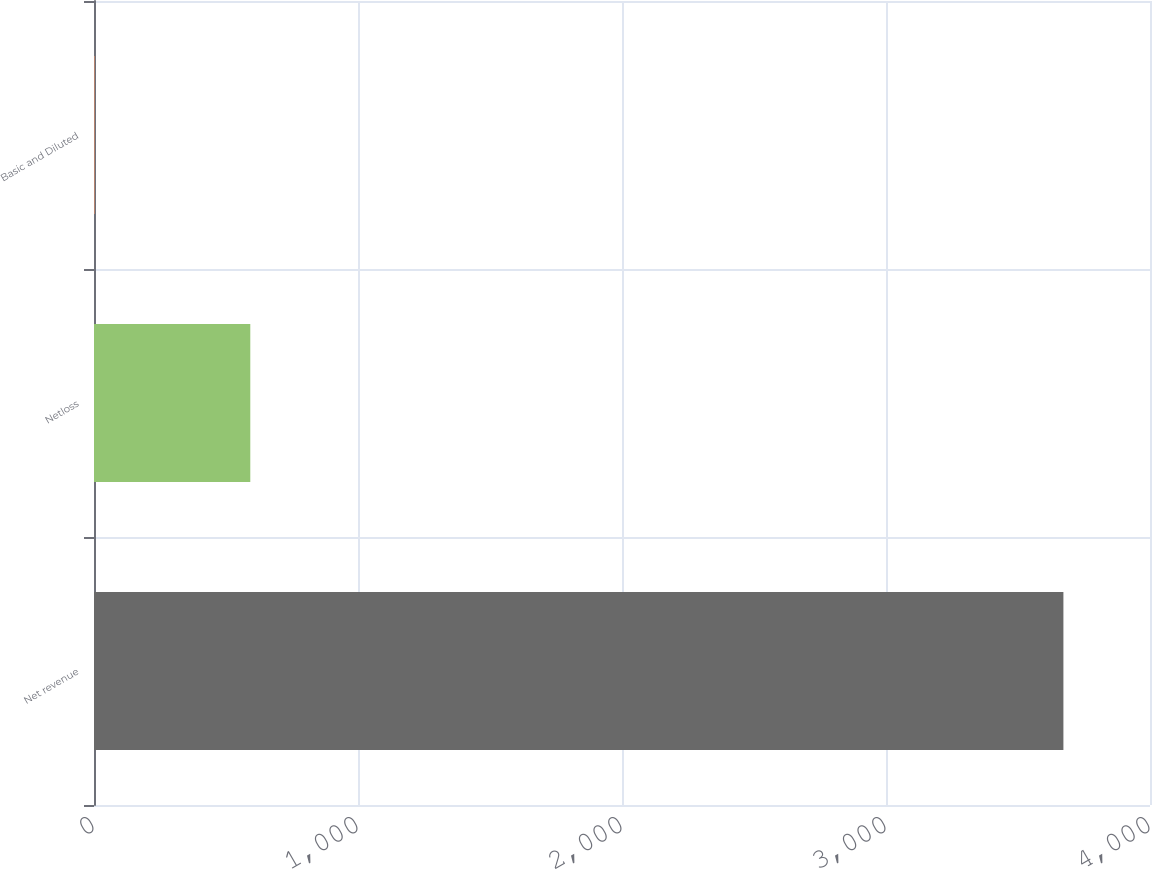<chart> <loc_0><loc_0><loc_500><loc_500><bar_chart><fcel>Net revenue<fcel>Netloss<fcel>Basic and Diluted<nl><fcel>3672<fcel>592<fcel>1.89<nl></chart> 